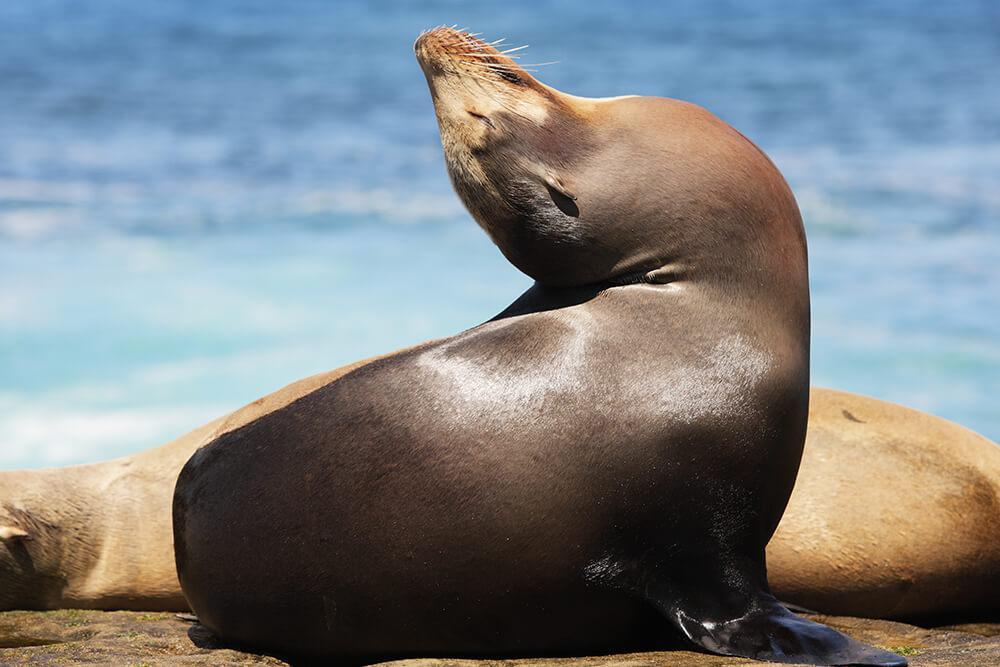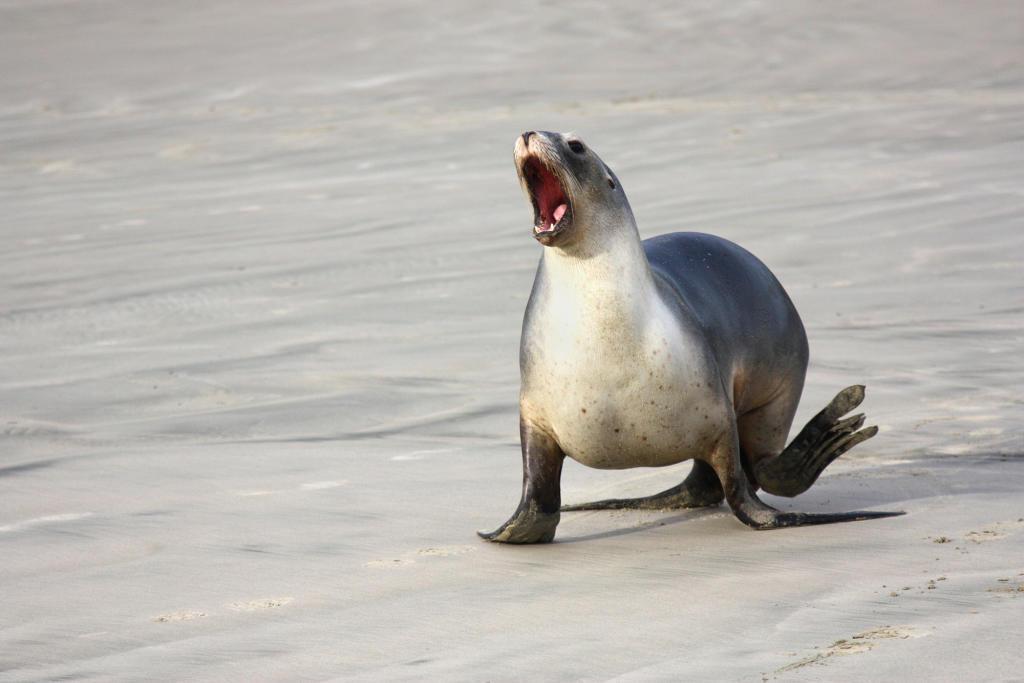The first image is the image on the left, the second image is the image on the right. Analyze the images presented: Is the assertion "There is a bird in the image on the left." valid? Answer yes or no. No. The first image is the image on the left, the second image is the image on the right. Evaluate the accuracy of this statement regarding the images: "Right image shows a seal on rocks in the center with a smaller animal to the left.". Is it true? Answer yes or no. No. 